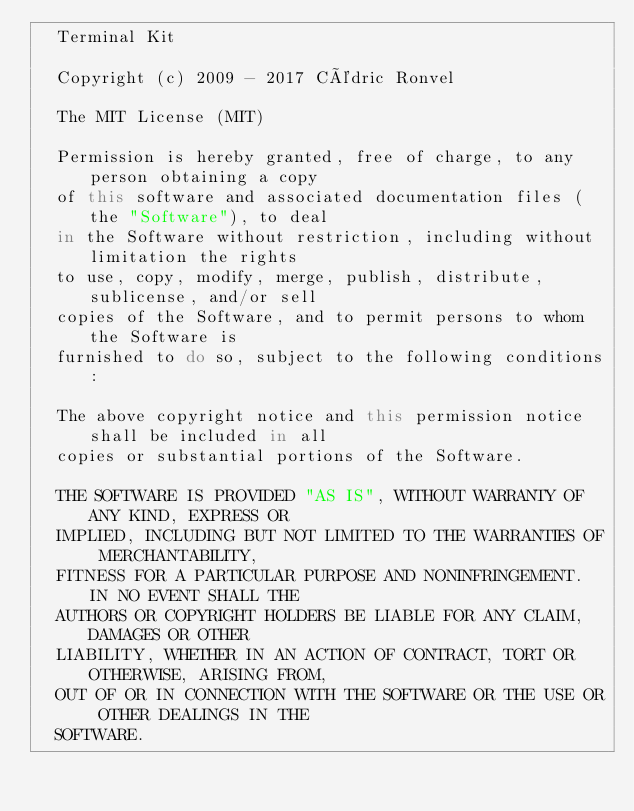<code> <loc_0><loc_0><loc_500><loc_500><_JavaScript_>	Terminal Kit
	
	Copyright (c) 2009 - 2017 Cédric Ronvel
	
	The MIT License (MIT)
	
	Permission is hereby granted, free of charge, to any person obtaining a copy
	of this software and associated documentation files (the "Software"), to deal
	in the Software without restriction, including without limitation the rights
	to use, copy, modify, merge, publish, distribute, sublicense, and/or sell
	copies of the Software, and to permit persons to whom the Software is
	furnished to do so, subject to the following conditions:
	
	The above copyright notice and this permission notice shall be included in all
	copies or substantial portions of the Software.
	
	THE SOFTWARE IS PROVIDED "AS IS", WITHOUT WARRANTY OF ANY KIND, EXPRESS OR
	IMPLIED, INCLUDING BUT NOT LIMITED TO THE WARRANTIES OF MERCHANTABILITY,
	FITNESS FOR A PARTICULAR PURPOSE AND NONINFRINGEMENT. IN NO EVENT SHALL THE
	AUTHORS OR COPYRIGHT HOLDERS BE LIABLE FOR ANY CLAIM, DAMAGES OR OTHER
	LIABILITY, WHETHER IN AN ACTION OF CONTRACT, TORT OR OTHERWISE, ARISING FROM,
	OUT OF OR IN CONNECTION WITH THE SOFTWARE OR THE USE OR OTHER DEALINGS IN THE
	SOFTWARE.</code> 